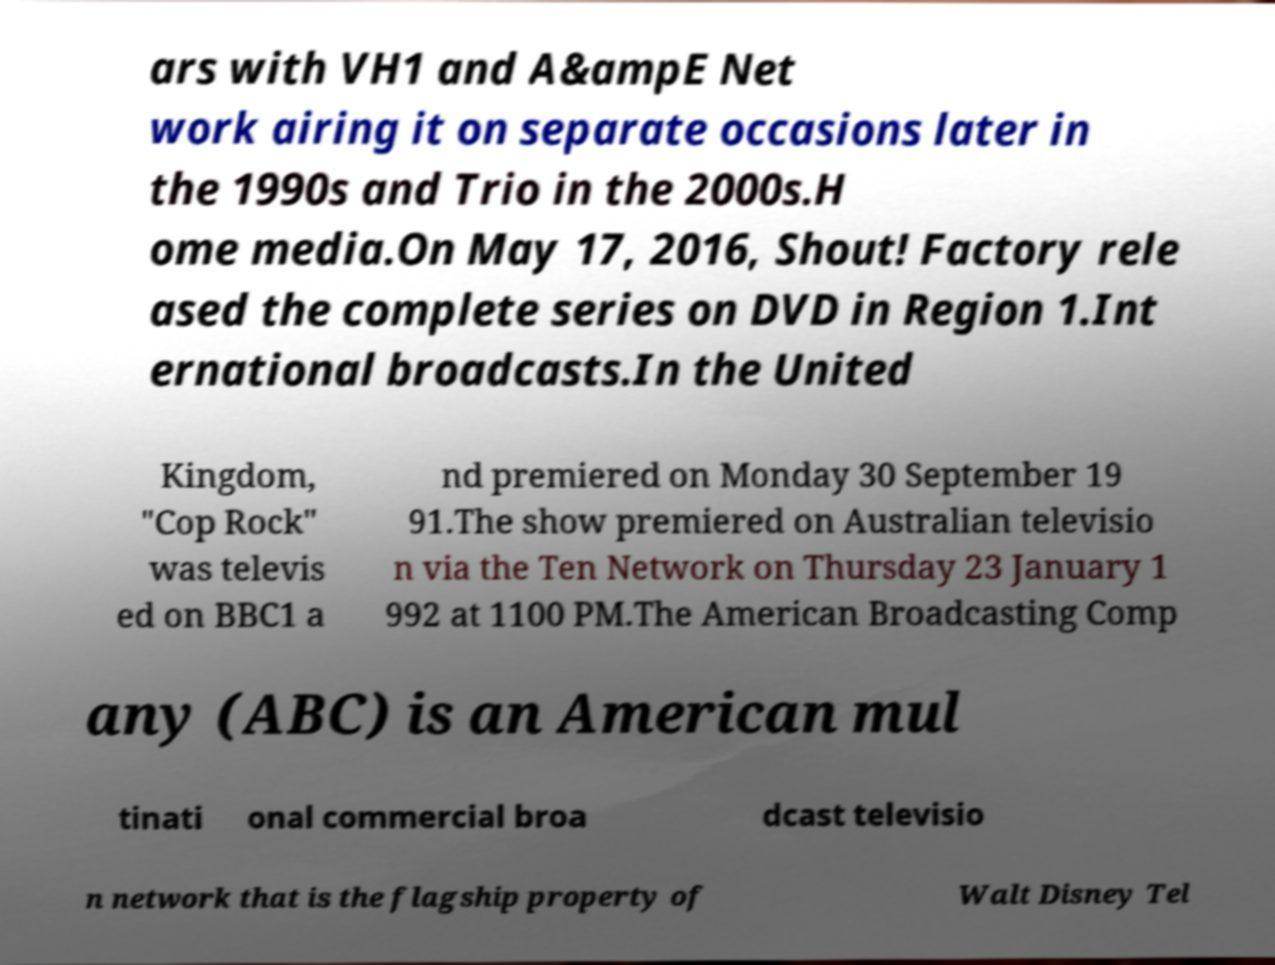For documentation purposes, I need the text within this image transcribed. Could you provide that? ars with VH1 and A&ampE Net work airing it on separate occasions later in the 1990s and Trio in the 2000s.H ome media.On May 17, 2016, Shout! Factory rele ased the complete series on DVD in Region 1.Int ernational broadcasts.In the United Kingdom, "Cop Rock" was televis ed on BBC1 a nd premiered on Monday 30 September 19 91.The show premiered on Australian televisio n via the Ten Network on Thursday 23 January 1 992 at 1100 PM.The American Broadcasting Comp any (ABC) is an American mul tinati onal commercial broa dcast televisio n network that is the flagship property of Walt Disney Tel 